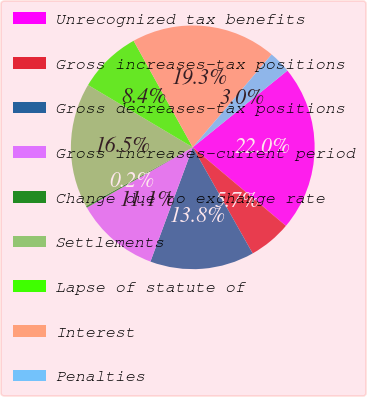<chart> <loc_0><loc_0><loc_500><loc_500><pie_chart><fcel>Unrecognized tax benefits<fcel>Gross increases-tax positions<fcel>Gross decreases-tax positions<fcel>Gross increases-current period<fcel>Change due to exchange rate<fcel>Settlements<fcel>Lapse of statute of<fcel>Interest<fcel>Penalties<nl><fcel>21.99%<fcel>5.67%<fcel>13.83%<fcel>11.11%<fcel>0.24%<fcel>16.55%<fcel>8.39%<fcel>19.27%<fcel>2.96%<nl></chart> 